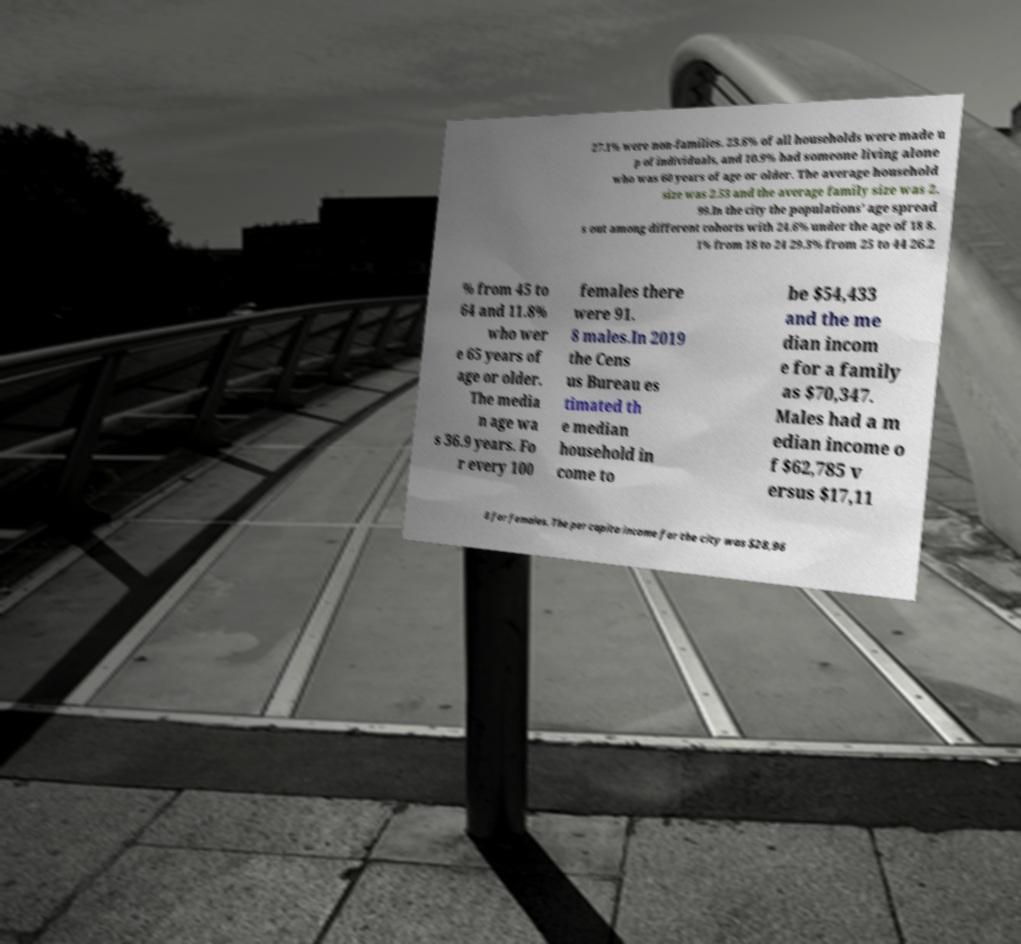Please identify and transcribe the text found in this image. 27.1% were non-families. 23.6% of all households were made u p of individuals, and 10.9% had someone living alone who was 60 years of age or older. The average household size was 2.53 and the average family size was 2. 99.In the city the populations' age spread s out among different cohorts with 24.6% under the age of 18 8. 1% from 18 to 24 29.3% from 25 to 44 26.2 % from 45 to 64 and 11.8% who wer e 65 years of age or older. The media n age wa s 36.9 years. Fo r every 100 females there were 91. 8 males.In 2019 the Cens us Bureau es timated th e median household in come to be $54,433 and the me dian incom e for a family as $70,347. Males had a m edian income o f $62,785 v ersus $17,11 8 for females. The per capita income for the city was $28,96 